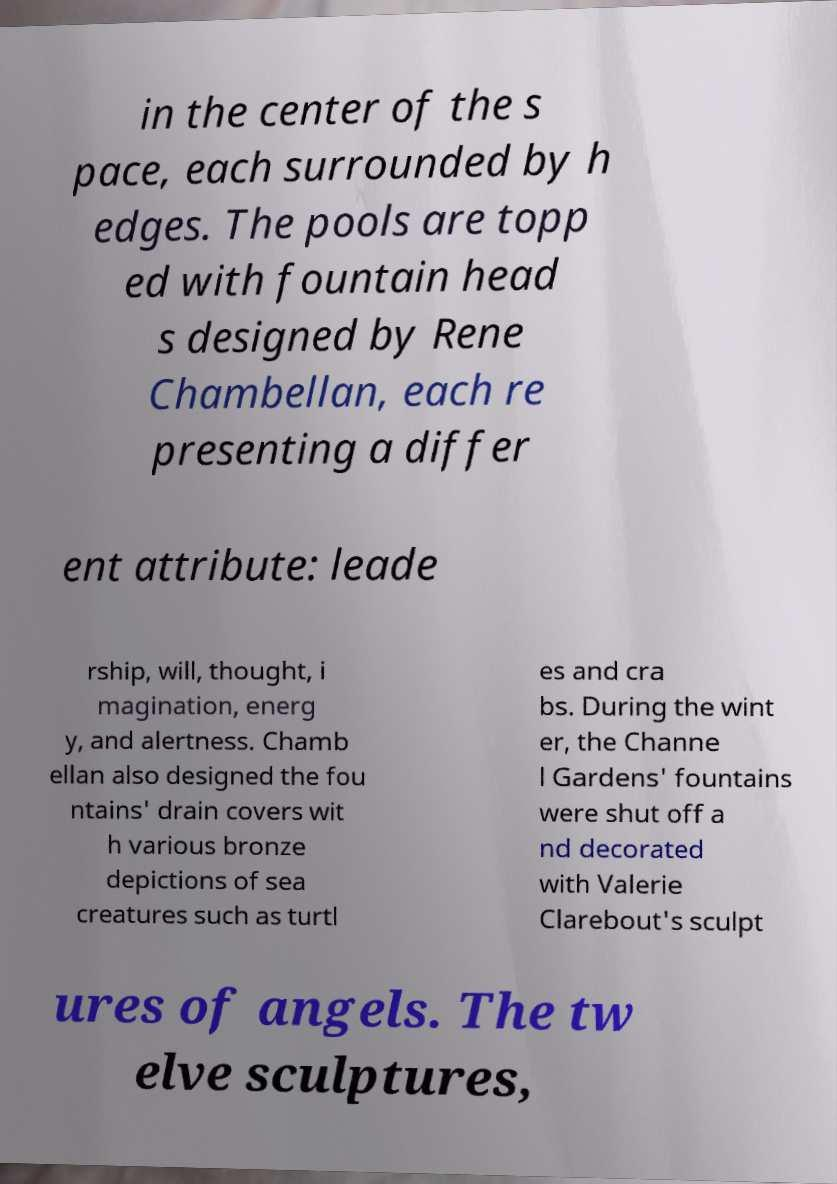What messages or text are displayed in this image? I need them in a readable, typed format. in the center of the s pace, each surrounded by h edges. The pools are topp ed with fountain head s designed by Rene Chambellan, each re presenting a differ ent attribute: leade rship, will, thought, i magination, energ y, and alertness. Chamb ellan also designed the fou ntains' drain covers wit h various bronze depictions of sea creatures such as turtl es and cra bs. During the wint er, the Channe l Gardens' fountains were shut off a nd decorated with Valerie Clarebout's sculpt ures of angels. The tw elve sculptures, 